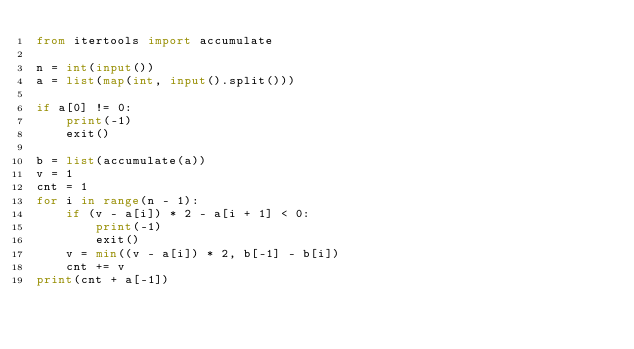Convert code to text. <code><loc_0><loc_0><loc_500><loc_500><_Python_>from itertools import accumulate

n = int(input())
a = list(map(int, input().split()))

if a[0] != 0:
    print(-1)
    exit()

b = list(accumulate(a))
v = 1
cnt = 1
for i in range(n - 1):
    if (v - a[i]) * 2 - a[i + 1] < 0:
        print(-1)
        exit()
    v = min((v - a[i]) * 2, b[-1] - b[i])
    cnt += v
print(cnt + a[-1])</code> 